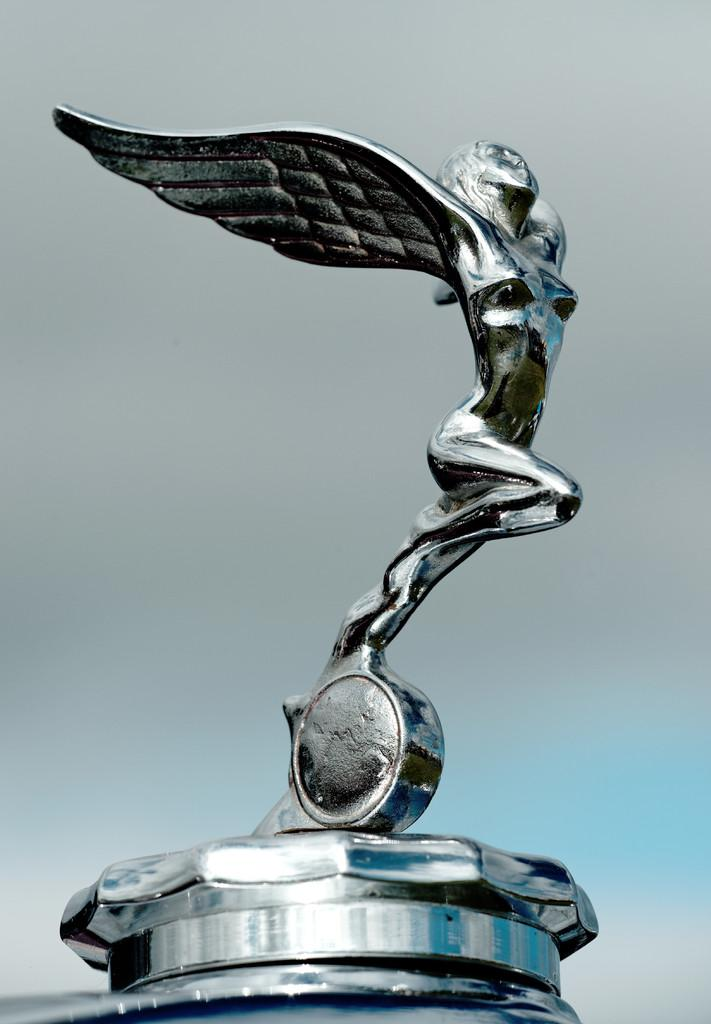What is the main subject of the image? The main subject of the image is a logo of a car. How many icicles are hanging from the car logo in the image? There are no icicles present in the image; it features a car logo. What type of meal is being prepared in the image? There is no meal preparation or any food items visible in the image; it only features a car logo. 